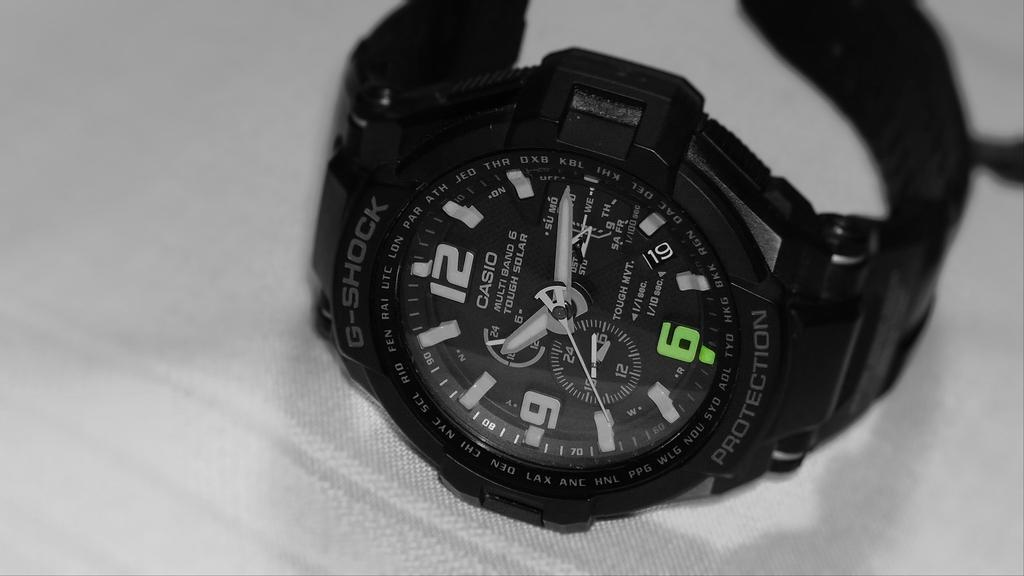<image>
Write a terse but informative summary of the picture. A black G-shock watch sits on its side telling us it is a quarter past ten. 